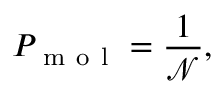Convert formula to latex. <formula><loc_0><loc_0><loc_500><loc_500>P _ { m o l } = \frac { 1 } { \mathcal { N } } ,</formula> 